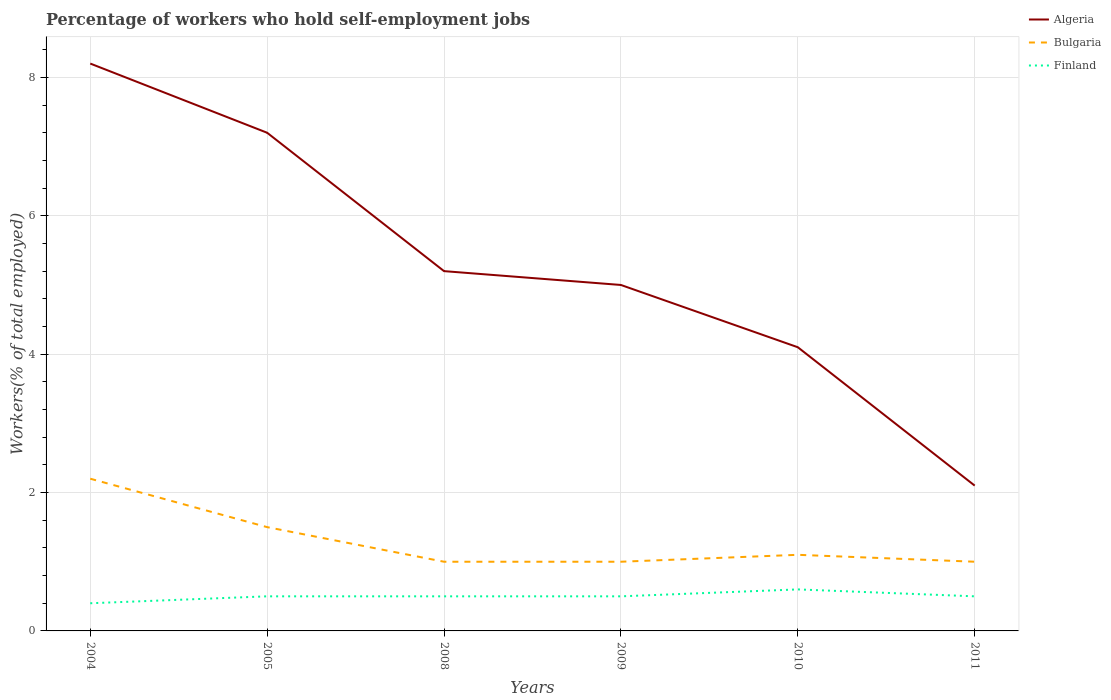Does the line corresponding to Finland intersect with the line corresponding to Bulgaria?
Your response must be concise. No. Is the number of lines equal to the number of legend labels?
Make the answer very short. Yes. In which year was the percentage of self-employed workers in Bulgaria maximum?
Your answer should be compact. 2008. What is the total percentage of self-employed workers in Algeria in the graph?
Offer a terse response. 2.2. What is the difference between the highest and the second highest percentage of self-employed workers in Bulgaria?
Offer a terse response. 1.2. Is the percentage of self-employed workers in Algeria strictly greater than the percentage of self-employed workers in Bulgaria over the years?
Ensure brevity in your answer.  No. How many lines are there?
Ensure brevity in your answer.  3. How many years are there in the graph?
Give a very brief answer. 6. Does the graph contain any zero values?
Make the answer very short. No. How are the legend labels stacked?
Provide a succinct answer. Vertical. What is the title of the graph?
Your answer should be very brief. Percentage of workers who hold self-employment jobs. Does "New Caledonia" appear as one of the legend labels in the graph?
Offer a very short reply. No. What is the label or title of the X-axis?
Your response must be concise. Years. What is the label or title of the Y-axis?
Your answer should be very brief. Workers(% of total employed). What is the Workers(% of total employed) of Algeria in 2004?
Your answer should be compact. 8.2. What is the Workers(% of total employed) in Bulgaria in 2004?
Your answer should be very brief. 2.2. What is the Workers(% of total employed) in Finland in 2004?
Provide a short and direct response. 0.4. What is the Workers(% of total employed) of Algeria in 2005?
Make the answer very short. 7.2. What is the Workers(% of total employed) in Bulgaria in 2005?
Your response must be concise. 1.5. What is the Workers(% of total employed) of Algeria in 2008?
Offer a terse response. 5.2. What is the Workers(% of total employed) of Finland in 2008?
Provide a short and direct response. 0.5. What is the Workers(% of total employed) of Finland in 2009?
Provide a succinct answer. 0.5. What is the Workers(% of total employed) of Algeria in 2010?
Provide a short and direct response. 4.1. What is the Workers(% of total employed) in Bulgaria in 2010?
Give a very brief answer. 1.1. What is the Workers(% of total employed) of Finland in 2010?
Keep it short and to the point. 0.6. What is the Workers(% of total employed) in Algeria in 2011?
Your answer should be very brief. 2.1. What is the Workers(% of total employed) in Finland in 2011?
Provide a short and direct response. 0.5. Across all years, what is the maximum Workers(% of total employed) of Algeria?
Provide a short and direct response. 8.2. Across all years, what is the maximum Workers(% of total employed) in Bulgaria?
Your answer should be compact. 2.2. Across all years, what is the maximum Workers(% of total employed) in Finland?
Offer a very short reply. 0.6. Across all years, what is the minimum Workers(% of total employed) of Algeria?
Your answer should be compact. 2.1. Across all years, what is the minimum Workers(% of total employed) in Finland?
Give a very brief answer. 0.4. What is the total Workers(% of total employed) of Algeria in the graph?
Your response must be concise. 31.8. What is the total Workers(% of total employed) in Finland in the graph?
Make the answer very short. 3. What is the difference between the Workers(% of total employed) of Bulgaria in 2004 and that in 2005?
Offer a very short reply. 0.7. What is the difference between the Workers(% of total employed) in Algeria in 2004 and that in 2008?
Your answer should be very brief. 3. What is the difference between the Workers(% of total employed) of Bulgaria in 2004 and that in 2008?
Offer a terse response. 1.2. What is the difference between the Workers(% of total employed) of Finland in 2004 and that in 2008?
Offer a terse response. -0.1. What is the difference between the Workers(% of total employed) of Algeria in 2004 and that in 2009?
Offer a very short reply. 3.2. What is the difference between the Workers(% of total employed) of Finland in 2004 and that in 2009?
Offer a terse response. -0.1. What is the difference between the Workers(% of total employed) of Algeria in 2004 and that in 2010?
Offer a very short reply. 4.1. What is the difference between the Workers(% of total employed) in Algeria in 2005 and that in 2008?
Your answer should be very brief. 2. What is the difference between the Workers(% of total employed) of Bulgaria in 2005 and that in 2008?
Your answer should be compact. 0.5. What is the difference between the Workers(% of total employed) of Finland in 2005 and that in 2009?
Ensure brevity in your answer.  0. What is the difference between the Workers(% of total employed) of Algeria in 2005 and that in 2010?
Your response must be concise. 3.1. What is the difference between the Workers(% of total employed) of Finland in 2005 and that in 2010?
Make the answer very short. -0.1. What is the difference between the Workers(% of total employed) of Bulgaria in 2005 and that in 2011?
Your answer should be very brief. 0.5. What is the difference between the Workers(% of total employed) of Finland in 2005 and that in 2011?
Keep it short and to the point. 0. What is the difference between the Workers(% of total employed) of Algeria in 2008 and that in 2009?
Keep it short and to the point. 0.2. What is the difference between the Workers(% of total employed) of Bulgaria in 2008 and that in 2009?
Your response must be concise. 0. What is the difference between the Workers(% of total employed) of Finland in 2008 and that in 2009?
Provide a succinct answer. 0. What is the difference between the Workers(% of total employed) in Finland in 2008 and that in 2010?
Your answer should be very brief. -0.1. What is the difference between the Workers(% of total employed) in Finland in 2008 and that in 2011?
Your response must be concise. 0. What is the difference between the Workers(% of total employed) in Algeria in 2009 and that in 2010?
Provide a short and direct response. 0.9. What is the difference between the Workers(% of total employed) of Algeria in 2009 and that in 2011?
Offer a terse response. 2.9. What is the difference between the Workers(% of total employed) in Bulgaria in 2009 and that in 2011?
Offer a very short reply. 0. What is the difference between the Workers(% of total employed) of Finland in 2009 and that in 2011?
Your answer should be compact. 0. What is the difference between the Workers(% of total employed) in Algeria in 2004 and the Workers(% of total employed) in Bulgaria in 2005?
Provide a short and direct response. 6.7. What is the difference between the Workers(% of total employed) of Algeria in 2004 and the Workers(% of total employed) of Bulgaria in 2008?
Provide a short and direct response. 7.2. What is the difference between the Workers(% of total employed) in Algeria in 2004 and the Workers(% of total employed) in Finland in 2008?
Offer a terse response. 7.7. What is the difference between the Workers(% of total employed) of Bulgaria in 2004 and the Workers(% of total employed) of Finland in 2008?
Your response must be concise. 1.7. What is the difference between the Workers(% of total employed) in Algeria in 2004 and the Workers(% of total employed) in Bulgaria in 2009?
Make the answer very short. 7.2. What is the difference between the Workers(% of total employed) of Algeria in 2004 and the Workers(% of total employed) of Finland in 2009?
Keep it short and to the point. 7.7. What is the difference between the Workers(% of total employed) of Algeria in 2004 and the Workers(% of total employed) of Finland in 2010?
Provide a short and direct response. 7.6. What is the difference between the Workers(% of total employed) in Algeria in 2004 and the Workers(% of total employed) in Bulgaria in 2011?
Ensure brevity in your answer.  7.2. What is the difference between the Workers(% of total employed) of Bulgaria in 2004 and the Workers(% of total employed) of Finland in 2011?
Provide a succinct answer. 1.7. What is the difference between the Workers(% of total employed) of Bulgaria in 2005 and the Workers(% of total employed) of Finland in 2008?
Your answer should be very brief. 1. What is the difference between the Workers(% of total employed) of Algeria in 2005 and the Workers(% of total employed) of Bulgaria in 2009?
Make the answer very short. 6.2. What is the difference between the Workers(% of total employed) in Algeria in 2005 and the Workers(% of total employed) in Finland in 2009?
Offer a very short reply. 6.7. What is the difference between the Workers(% of total employed) in Algeria in 2005 and the Workers(% of total employed) in Bulgaria in 2010?
Provide a succinct answer. 6.1. What is the difference between the Workers(% of total employed) in Bulgaria in 2005 and the Workers(% of total employed) in Finland in 2010?
Your response must be concise. 0.9. What is the difference between the Workers(% of total employed) in Algeria in 2005 and the Workers(% of total employed) in Bulgaria in 2011?
Your response must be concise. 6.2. What is the difference between the Workers(% of total employed) of Algeria in 2008 and the Workers(% of total employed) of Bulgaria in 2009?
Offer a terse response. 4.2. What is the difference between the Workers(% of total employed) in Algeria in 2008 and the Workers(% of total employed) in Finland in 2009?
Provide a succinct answer. 4.7. What is the difference between the Workers(% of total employed) in Algeria in 2008 and the Workers(% of total employed) in Bulgaria in 2010?
Make the answer very short. 4.1. What is the difference between the Workers(% of total employed) in Algeria in 2008 and the Workers(% of total employed) in Finland in 2010?
Keep it short and to the point. 4.6. What is the difference between the Workers(% of total employed) of Bulgaria in 2008 and the Workers(% of total employed) of Finland in 2010?
Provide a short and direct response. 0.4. What is the difference between the Workers(% of total employed) of Algeria in 2008 and the Workers(% of total employed) of Finland in 2011?
Ensure brevity in your answer.  4.7. What is the difference between the Workers(% of total employed) in Bulgaria in 2008 and the Workers(% of total employed) in Finland in 2011?
Provide a succinct answer. 0.5. What is the difference between the Workers(% of total employed) of Algeria in 2009 and the Workers(% of total employed) of Bulgaria in 2011?
Your answer should be compact. 4. What is the difference between the Workers(% of total employed) in Algeria in 2009 and the Workers(% of total employed) in Finland in 2011?
Ensure brevity in your answer.  4.5. What is the difference between the Workers(% of total employed) of Bulgaria in 2009 and the Workers(% of total employed) of Finland in 2011?
Your answer should be compact. 0.5. What is the average Workers(% of total employed) of Algeria per year?
Provide a short and direct response. 5.3. In the year 2004, what is the difference between the Workers(% of total employed) of Algeria and Workers(% of total employed) of Bulgaria?
Your answer should be compact. 6. In the year 2004, what is the difference between the Workers(% of total employed) of Bulgaria and Workers(% of total employed) of Finland?
Your answer should be very brief. 1.8. In the year 2005, what is the difference between the Workers(% of total employed) of Algeria and Workers(% of total employed) of Bulgaria?
Offer a very short reply. 5.7. In the year 2005, what is the difference between the Workers(% of total employed) in Algeria and Workers(% of total employed) in Finland?
Your answer should be compact. 6.7. In the year 2005, what is the difference between the Workers(% of total employed) in Bulgaria and Workers(% of total employed) in Finland?
Your answer should be very brief. 1. In the year 2008, what is the difference between the Workers(% of total employed) in Algeria and Workers(% of total employed) in Finland?
Provide a succinct answer. 4.7. In the year 2009, what is the difference between the Workers(% of total employed) of Algeria and Workers(% of total employed) of Bulgaria?
Make the answer very short. 4. In the year 2009, what is the difference between the Workers(% of total employed) in Bulgaria and Workers(% of total employed) in Finland?
Your answer should be compact. 0.5. In the year 2011, what is the difference between the Workers(% of total employed) in Algeria and Workers(% of total employed) in Finland?
Provide a succinct answer. 1.6. In the year 2011, what is the difference between the Workers(% of total employed) of Bulgaria and Workers(% of total employed) of Finland?
Offer a very short reply. 0.5. What is the ratio of the Workers(% of total employed) in Algeria in 2004 to that in 2005?
Offer a very short reply. 1.14. What is the ratio of the Workers(% of total employed) in Bulgaria in 2004 to that in 2005?
Your answer should be very brief. 1.47. What is the ratio of the Workers(% of total employed) in Finland in 2004 to that in 2005?
Your answer should be very brief. 0.8. What is the ratio of the Workers(% of total employed) of Algeria in 2004 to that in 2008?
Your response must be concise. 1.58. What is the ratio of the Workers(% of total employed) in Bulgaria in 2004 to that in 2008?
Provide a succinct answer. 2.2. What is the ratio of the Workers(% of total employed) of Algeria in 2004 to that in 2009?
Ensure brevity in your answer.  1.64. What is the ratio of the Workers(% of total employed) in Bulgaria in 2004 to that in 2009?
Make the answer very short. 2.2. What is the ratio of the Workers(% of total employed) of Finland in 2004 to that in 2009?
Ensure brevity in your answer.  0.8. What is the ratio of the Workers(% of total employed) in Algeria in 2004 to that in 2010?
Provide a succinct answer. 2. What is the ratio of the Workers(% of total employed) in Bulgaria in 2004 to that in 2010?
Ensure brevity in your answer.  2. What is the ratio of the Workers(% of total employed) of Algeria in 2004 to that in 2011?
Make the answer very short. 3.9. What is the ratio of the Workers(% of total employed) of Finland in 2004 to that in 2011?
Provide a succinct answer. 0.8. What is the ratio of the Workers(% of total employed) of Algeria in 2005 to that in 2008?
Provide a succinct answer. 1.38. What is the ratio of the Workers(% of total employed) of Algeria in 2005 to that in 2009?
Provide a succinct answer. 1.44. What is the ratio of the Workers(% of total employed) of Algeria in 2005 to that in 2010?
Provide a succinct answer. 1.76. What is the ratio of the Workers(% of total employed) in Bulgaria in 2005 to that in 2010?
Offer a very short reply. 1.36. What is the ratio of the Workers(% of total employed) of Algeria in 2005 to that in 2011?
Keep it short and to the point. 3.43. What is the ratio of the Workers(% of total employed) in Bulgaria in 2005 to that in 2011?
Ensure brevity in your answer.  1.5. What is the ratio of the Workers(% of total employed) of Finland in 2005 to that in 2011?
Give a very brief answer. 1. What is the ratio of the Workers(% of total employed) of Bulgaria in 2008 to that in 2009?
Your answer should be compact. 1. What is the ratio of the Workers(% of total employed) of Algeria in 2008 to that in 2010?
Your answer should be compact. 1.27. What is the ratio of the Workers(% of total employed) of Bulgaria in 2008 to that in 2010?
Keep it short and to the point. 0.91. What is the ratio of the Workers(% of total employed) in Finland in 2008 to that in 2010?
Your answer should be very brief. 0.83. What is the ratio of the Workers(% of total employed) in Algeria in 2008 to that in 2011?
Keep it short and to the point. 2.48. What is the ratio of the Workers(% of total employed) of Bulgaria in 2008 to that in 2011?
Provide a succinct answer. 1. What is the ratio of the Workers(% of total employed) in Finland in 2008 to that in 2011?
Your answer should be very brief. 1. What is the ratio of the Workers(% of total employed) in Algeria in 2009 to that in 2010?
Your answer should be very brief. 1.22. What is the ratio of the Workers(% of total employed) of Bulgaria in 2009 to that in 2010?
Offer a terse response. 0.91. What is the ratio of the Workers(% of total employed) in Algeria in 2009 to that in 2011?
Make the answer very short. 2.38. What is the ratio of the Workers(% of total employed) in Finland in 2009 to that in 2011?
Provide a short and direct response. 1. What is the ratio of the Workers(% of total employed) of Algeria in 2010 to that in 2011?
Keep it short and to the point. 1.95. What is the ratio of the Workers(% of total employed) of Finland in 2010 to that in 2011?
Ensure brevity in your answer.  1.2. What is the difference between the highest and the second highest Workers(% of total employed) in Bulgaria?
Your answer should be very brief. 0.7. What is the difference between the highest and the second highest Workers(% of total employed) in Finland?
Provide a succinct answer. 0.1. 